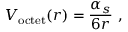Convert formula to latex. <formula><loc_0><loc_0><loc_500><loc_500>V _ { o c t e t } ( r ) = { \frac { \alpha _ { s } } { 6 r } } \ ,</formula> 